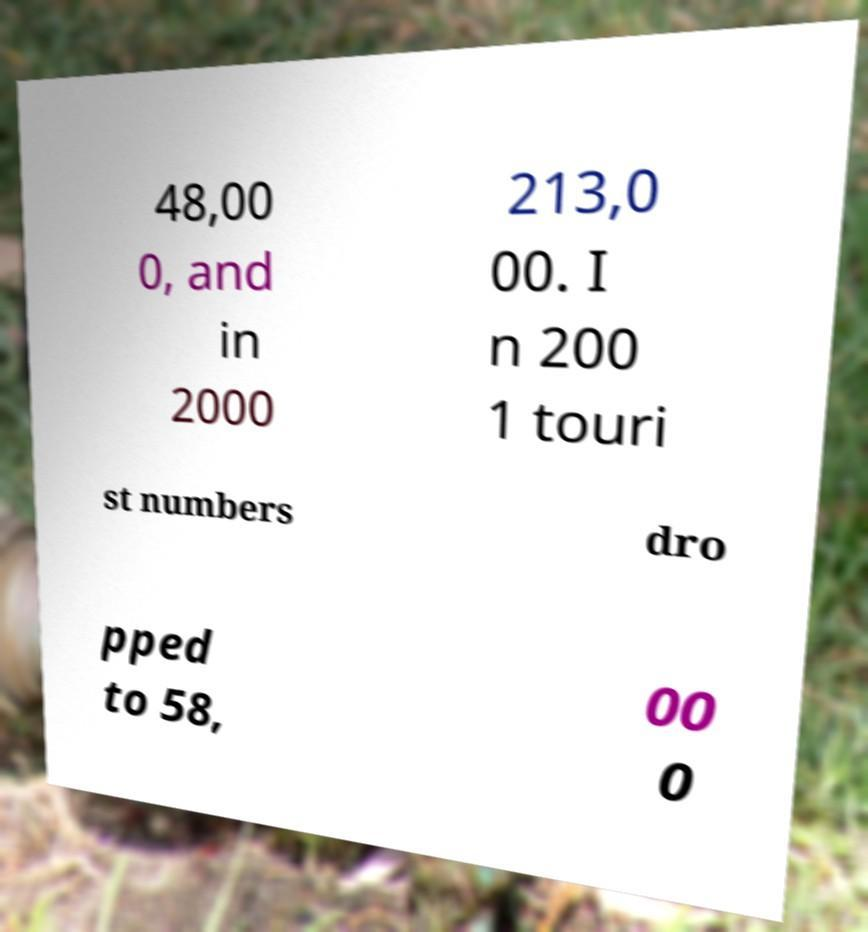What messages or text are displayed in this image? I need them in a readable, typed format. 48,00 0, and in 2000 213,0 00. I n 200 1 touri st numbers dro pped to 58, 00 0 